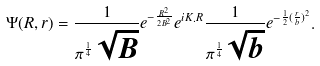<formula> <loc_0><loc_0><loc_500><loc_500>\Psi ( R , r ) = \frac { 1 } { \pi ^ { \frac { 1 } { 4 } } \sqrt { B } } e ^ { - \frac { R ^ { 2 } } { 2 B ^ { 2 } } } e ^ { i K . R } \frac { 1 } { \pi ^ { \frac { 1 } { 4 } } \sqrt { b } } e ^ { - \frac { 1 } { 2 } { ( \frac { r } { b } ) } ^ { 2 } } .</formula> 